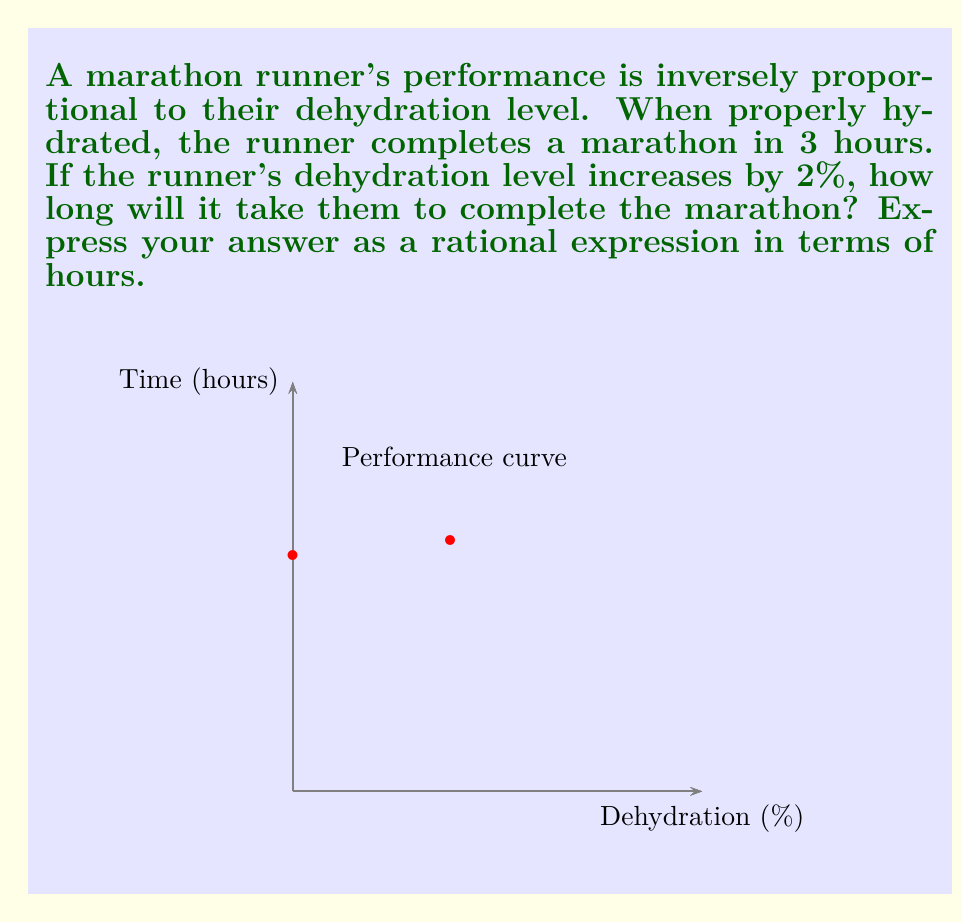Help me with this question. Let's approach this step-by-step:

1) Let $t$ be the time to complete the marathon and $d$ be the dehydration level.

2) The inverse proportion relationship can be expressed as:

   $t = \frac{k}{1-\frac{d}{100}}$

   where $k$ is a constant.

3) When properly hydrated ($d=0$), $t=3$. So:

   $3 = \frac{k}{1-\frac{0}{100}} = k$

4) Therefore, our equation becomes:

   $t = \frac{3}{1-\frac{d}{100}}$

5) Now, we need to find $t$ when $d=2$:

   $t = \frac{3}{1-\frac{2}{100}} = \frac{3}{1-0.02} = \frac{3}{0.98}$

6) To simplify:

   $\frac{3}{0.98} = \frac{300}{98} = \frac{150}{49} \approx 3.1875$

Thus, it will take the runner $\frac{150}{49}$ hours to complete the marathon.
Answer: $\frac{150}{49}$ hours 